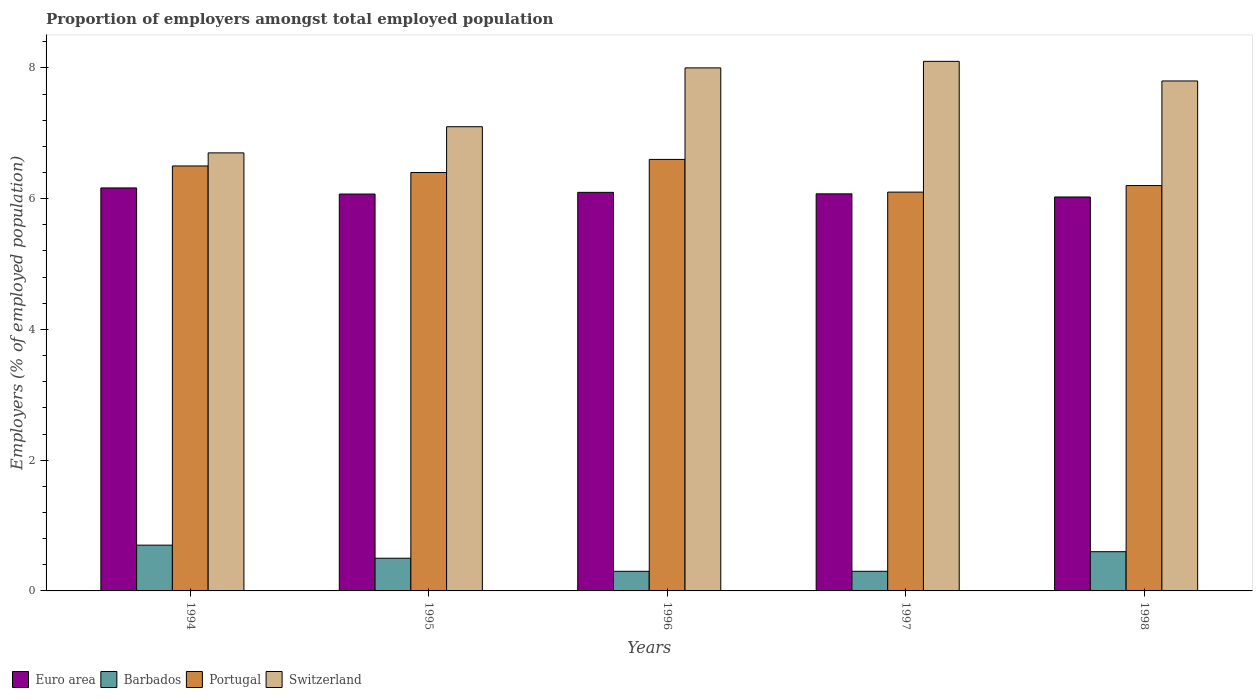How many groups of bars are there?
Provide a short and direct response. 5. Are the number of bars per tick equal to the number of legend labels?
Offer a very short reply. Yes. How many bars are there on the 3rd tick from the right?
Provide a succinct answer. 4. What is the proportion of employers in Portugal in 1996?
Provide a succinct answer. 6.6. Across all years, what is the maximum proportion of employers in Switzerland?
Your response must be concise. 8.1. Across all years, what is the minimum proportion of employers in Barbados?
Your answer should be very brief. 0.3. In which year was the proportion of employers in Switzerland maximum?
Keep it short and to the point. 1997. What is the total proportion of employers in Switzerland in the graph?
Give a very brief answer. 37.7. What is the difference between the proportion of employers in Euro area in 1994 and that in 1997?
Make the answer very short. 0.09. What is the difference between the proportion of employers in Portugal in 1996 and the proportion of employers in Switzerland in 1994?
Provide a short and direct response. -0.1. What is the average proportion of employers in Portugal per year?
Keep it short and to the point. 6.36. In the year 1998, what is the difference between the proportion of employers in Switzerland and proportion of employers in Barbados?
Your response must be concise. 7.2. In how many years, is the proportion of employers in Barbados greater than 0.4 %?
Give a very brief answer. 3. What is the ratio of the proportion of employers in Euro area in 1995 to that in 1997?
Ensure brevity in your answer.  1. Is the difference between the proportion of employers in Switzerland in 1996 and 1997 greater than the difference between the proportion of employers in Barbados in 1996 and 1997?
Ensure brevity in your answer.  No. What is the difference between the highest and the second highest proportion of employers in Switzerland?
Provide a succinct answer. 0.1. What is the difference between the highest and the lowest proportion of employers in Portugal?
Your answer should be very brief. 0.5. Is the sum of the proportion of employers in Barbados in 1994 and 1998 greater than the maximum proportion of employers in Portugal across all years?
Your answer should be very brief. No. What does the 4th bar from the left in 1996 represents?
Your answer should be very brief. Switzerland. What does the 3rd bar from the right in 1994 represents?
Keep it short and to the point. Barbados. How many bars are there?
Make the answer very short. 20. Are the values on the major ticks of Y-axis written in scientific E-notation?
Keep it short and to the point. No. Does the graph contain grids?
Your response must be concise. No. How are the legend labels stacked?
Ensure brevity in your answer.  Horizontal. What is the title of the graph?
Your response must be concise. Proportion of employers amongst total employed population. What is the label or title of the Y-axis?
Your answer should be very brief. Employers (% of employed population). What is the Employers (% of employed population) of Euro area in 1994?
Ensure brevity in your answer.  6.16. What is the Employers (% of employed population) of Barbados in 1994?
Make the answer very short. 0.7. What is the Employers (% of employed population) in Portugal in 1994?
Your response must be concise. 6.5. What is the Employers (% of employed population) of Switzerland in 1994?
Ensure brevity in your answer.  6.7. What is the Employers (% of employed population) of Euro area in 1995?
Your answer should be very brief. 6.07. What is the Employers (% of employed population) of Portugal in 1995?
Your answer should be very brief. 6.4. What is the Employers (% of employed population) in Switzerland in 1995?
Your response must be concise. 7.1. What is the Employers (% of employed population) in Euro area in 1996?
Your response must be concise. 6.1. What is the Employers (% of employed population) of Barbados in 1996?
Provide a succinct answer. 0.3. What is the Employers (% of employed population) of Portugal in 1996?
Ensure brevity in your answer.  6.6. What is the Employers (% of employed population) in Switzerland in 1996?
Your answer should be compact. 8. What is the Employers (% of employed population) of Euro area in 1997?
Give a very brief answer. 6.07. What is the Employers (% of employed population) in Barbados in 1997?
Ensure brevity in your answer.  0.3. What is the Employers (% of employed population) in Portugal in 1997?
Keep it short and to the point. 6.1. What is the Employers (% of employed population) of Switzerland in 1997?
Offer a very short reply. 8.1. What is the Employers (% of employed population) of Euro area in 1998?
Provide a succinct answer. 6.03. What is the Employers (% of employed population) in Barbados in 1998?
Your answer should be compact. 0.6. What is the Employers (% of employed population) in Portugal in 1998?
Your response must be concise. 6.2. What is the Employers (% of employed population) in Switzerland in 1998?
Offer a terse response. 7.8. Across all years, what is the maximum Employers (% of employed population) in Euro area?
Your answer should be very brief. 6.16. Across all years, what is the maximum Employers (% of employed population) of Barbados?
Offer a very short reply. 0.7. Across all years, what is the maximum Employers (% of employed population) of Portugal?
Offer a terse response. 6.6. Across all years, what is the maximum Employers (% of employed population) of Switzerland?
Keep it short and to the point. 8.1. Across all years, what is the minimum Employers (% of employed population) in Euro area?
Make the answer very short. 6.03. Across all years, what is the minimum Employers (% of employed population) of Barbados?
Provide a succinct answer. 0.3. Across all years, what is the minimum Employers (% of employed population) of Portugal?
Your answer should be compact. 6.1. Across all years, what is the minimum Employers (% of employed population) of Switzerland?
Keep it short and to the point. 6.7. What is the total Employers (% of employed population) in Euro area in the graph?
Offer a terse response. 30.43. What is the total Employers (% of employed population) of Barbados in the graph?
Offer a terse response. 2.4. What is the total Employers (% of employed population) of Portugal in the graph?
Your response must be concise. 31.8. What is the total Employers (% of employed population) in Switzerland in the graph?
Provide a succinct answer. 37.7. What is the difference between the Employers (% of employed population) of Euro area in 1994 and that in 1995?
Your response must be concise. 0.09. What is the difference between the Employers (% of employed population) in Barbados in 1994 and that in 1995?
Your response must be concise. 0.2. What is the difference between the Employers (% of employed population) in Portugal in 1994 and that in 1995?
Provide a succinct answer. 0.1. What is the difference between the Employers (% of employed population) in Switzerland in 1994 and that in 1995?
Your answer should be compact. -0.4. What is the difference between the Employers (% of employed population) of Euro area in 1994 and that in 1996?
Ensure brevity in your answer.  0.07. What is the difference between the Employers (% of employed population) in Barbados in 1994 and that in 1996?
Provide a succinct answer. 0.4. What is the difference between the Employers (% of employed population) of Switzerland in 1994 and that in 1996?
Provide a short and direct response. -1.3. What is the difference between the Employers (% of employed population) in Euro area in 1994 and that in 1997?
Your answer should be compact. 0.09. What is the difference between the Employers (% of employed population) in Euro area in 1994 and that in 1998?
Keep it short and to the point. 0.14. What is the difference between the Employers (% of employed population) of Portugal in 1994 and that in 1998?
Provide a short and direct response. 0.3. What is the difference between the Employers (% of employed population) of Euro area in 1995 and that in 1996?
Provide a succinct answer. -0.03. What is the difference between the Employers (% of employed population) in Switzerland in 1995 and that in 1996?
Keep it short and to the point. -0.9. What is the difference between the Employers (% of employed population) of Euro area in 1995 and that in 1997?
Your response must be concise. -0. What is the difference between the Employers (% of employed population) of Portugal in 1995 and that in 1997?
Keep it short and to the point. 0.3. What is the difference between the Employers (% of employed population) of Switzerland in 1995 and that in 1997?
Give a very brief answer. -1. What is the difference between the Employers (% of employed population) in Euro area in 1995 and that in 1998?
Give a very brief answer. 0.05. What is the difference between the Employers (% of employed population) of Portugal in 1995 and that in 1998?
Provide a short and direct response. 0.2. What is the difference between the Employers (% of employed population) in Euro area in 1996 and that in 1997?
Make the answer very short. 0.02. What is the difference between the Employers (% of employed population) in Portugal in 1996 and that in 1997?
Give a very brief answer. 0.5. What is the difference between the Employers (% of employed population) in Switzerland in 1996 and that in 1997?
Your response must be concise. -0.1. What is the difference between the Employers (% of employed population) of Euro area in 1996 and that in 1998?
Give a very brief answer. 0.07. What is the difference between the Employers (% of employed population) of Euro area in 1997 and that in 1998?
Your answer should be very brief. 0.05. What is the difference between the Employers (% of employed population) of Barbados in 1997 and that in 1998?
Keep it short and to the point. -0.3. What is the difference between the Employers (% of employed population) in Switzerland in 1997 and that in 1998?
Make the answer very short. 0.3. What is the difference between the Employers (% of employed population) in Euro area in 1994 and the Employers (% of employed population) in Barbados in 1995?
Your answer should be very brief. 5.66. What is the difference between the Employers (% of employed population) of Euro area in 1994 and the Employers (% of employed population) of Portugal in 1995?
Offer a very short reply. -0.24. What is the difference between the Employers (% of employed population) of Euro area in 1994 and the Employers (% of employed population) of Switzerland in 1995?
Ensure brevity in your answer.  -0.94. What is the difference between the Employers (% of employed population) in Barbados in 1994 and the Employers (% of employed population) in Portugal in 1995?
Your answer should be compact. -5.7. What is the difference between the Employers (% of employed population) in Barbados in 1994 and the Employers (% of employed population) in Switzerland in 1995?
Offer a very short reply. -6.4. What is the difference between the Employers (% of employed population) in Portugal in 1994 and the Employers (% of employed population) in Switzerland in 1995?
Your answer should be very brief. -0.6. What is the difference between the Employers (% of employed population) in Euro area in 1994 and the Employers (% of employed population) in Barbados in 1996?
Provide a succinct answer. 5.86. What is the difference between the Employers (% of employed population) of Euro area in 1994 and the Employers (% of employed population) of Portugal in 1996?
Offer a very short reply. -0.44. What is the difference between the Employers (% of employed population) in Euro area in 1994 and the Employers (% of employed population) in Switzerland in 1996?
Your answer should be very brief. -1.84. What is the difference between the Employers (% of employed population) of Barbados in 1994 and the Employers (% of employed population) of Switzerland in 1996?
Your answer should be compact. -7.3. What is the difference between the Employers (% of employed population) in Portugal in 1994 and the Employers (% of employed population) in Switzerland in 1996?
Your response must be concise. -1.5. What is the difference between the Employers (% of employed population) of Euro area in 1994 and the Employers (% of employed population) of Barbados in 1997?
Your answer should be compact. 5.86. What is the difference between the Employers (% of employed population) in Euro area in 1994 and the Employers (% of employed population) in Portugal in 1997?
Your answer should be very brief. 0.06. What is the difference between the Employers (% of employed population) of Euro area in 1994 and the Employers (% of employed population) of Switzerland in 1997?
Provide a succinct answer. -1.94. What is the difference between the Employers (% of employed population) in Barbados in 1994 and the Employers (% of employed population) in Portugal in 1997?
Your response must be concise. -5.4. What is the difference between the Employers (% of employed population) of Barbados in 1994 and the Employers (% of employed population) of Switzerland in 1997?
Keep it short and to the point. -7.4. What is the difference between the Employers (% of employed population) of Euro area in 1994 and the Employers (% of employed population) of Barbados in 1998?
Offer a terse response. 5.56. What is the difference between the Employers (% of employed population) in Euro area in 1994 and the Employers (% of employed population) in Portugal in 1998?
Provide a short and direct response. -0.04. What is the difference between the Employers (% of employed population) in Euro area in 1994 and the Employers (% of employed population) in Switzerland in 1998?
Ensure brevity in your answer.  -1.64. What is the difference between the Employers (% of employed population) in Portugal in 1994 and the Employers (% of employed population) in Switzerland in 1998?
Ensure brevity in your answer.  -1.3. What is the difference between the Employers (% of employed population) of Euro area in 1995 and the Employers (% of employed population) of Barbados in 1996?
Offer a terse response. 5.77. What is the difference between the Employers (% of employed population) in Euro area in 1995 and the Employers (% of employed population) in Portugal in 1996?
Make the answer very short. -0.53. What is the difference between the Employers (% of employed population) of Euro area in 1995 and the Employers (% of employed population) of Switzerland in 1996?
Ensure brevity in your answer.  -1.93. What is the difference between the Employers (% of employed population) of Barbados in 1995 and the Employers (% of employed population) of Portugal in 1996?
Provide a short and direct response. -6.1. What is the difference between the Employers (% of employed population) of Portugal in 1995 and the Employers (% of employed population) of Switzerland in 1996?
Give a very brief answer. -1.6. What is the difference between the Employers (% of employed population) in Euro area in 1995 and the Employers (% of employed population) in Barbados in 1997?
Provide a succinct answer. 5.77. What is the difference between the Employers (% of employed population) of Euro area in 1995 and the Employers (% of employed population) of Portugal in 1997?
Offer a terse response. -0.03. What is the difference between the Employers (% of employed population) of Euro area in 1995 and the Employers (% of employed population) of Switzerland in 1997?
Offer a terse response. -2.03. What is the difference between the Employers (% of employed population) in Barbados in 1995 and the Employers (% of employed population) in Portugal in 1997?
Your response must be concise. -5.6. What is the difference between the Employers (% of employed population) in Barbados in 1995 and the Employers (% of employed population) in Switzerland in 1997?
Ensure brevity in your answer.  -7.6. What is the difference between the Employers (% of employed population) of Portugal in 1995 and the Employers (% of employed population) of Switzerland in 1997?
Your answer should be compact. -1.7. What is the difference between the Employers (% of employed population) of Euro area in 1995 and the Employers (% of employed population) of Barbados in 1998?
Provide a short and direct response. 5.47. What is the difference between the Employers (% of employed population) in Euro area in 1995 and the Employers (% of employed population) in Portugal in 1998?
Provide a succinct answer. -0.13. What is the difference between the Employers (% of employed population) in Euro area in 1995 and the Employers (% of employed population) in Switzerland in 1998?
Provide a short and direct response. -1.73. What is the difference between the Employers (% of employed population) in Barbados in 1995 and the Employers (% of employed population) in Portugal in 1998?
Make the answer very short. -5.7. What is the difference between the Employers (% of employed population) in Barbados in 1995 and the Employers (% of employed population) in Switzerland in 1998?
Provide a succinct answer. -7.3. What is the difference between the Employers (% of employed population) in Portugal in 1995 and the Employers (% of employed population) in Switzerland in 1998?
Ensure brevity in your answer.  -1.4. What is the difference between the Employers (% of employed population) in Euro area in 1996 and the Employers (% of employed population) in Barbados in 1997?
Provide a succinct answer. 5.8. What is the difference between the Employers (% of employed population) in Euro area in 1996 and the Employers (% of employed population) in Portugal in 1997?
Provide a short and direct response. -0. What is the difference between the Employers (% of employed population) of Euro area in 1996 and the Employers (% of employed population) of Switzerland in 1997?
Make the answer very short. -2. What is the difference between the Employers (% of employed population) in Barbados in 1996 and the Employers (% of employed population) in Portugal in 1997?
Provide a succinct answer. -5.8. What is the difference between the Employers (% of employed population) of Barbados in 1996 and the Employers (% of employed population) of Switzerland in 1997?
Provide a succinct answer. -7.8. What is the difference between the Employers (% of employed population) in Portugal in 1996 and the Employers (% of employed population) in Switzerland in 1997?
Provide a short and direct response. -1.5. What is the difference between the Employers (% of employed population) in Euro area in 1996 and the Employers (% of employed population) in Barbados in 1998?
Keep it short and to the point. 5.5. What is the difference between the Employers (% of employed population) in Euro area in 1996 and the Employers (% of employed population) in Portugal in 1998?
Keep it short and to the point. -0.1. What is the difference between the Employers (% of employed population) in Euro area in 1996 and the Employers (% of employed population) in Switzerland in 1998?
Your answer should be compact. -1.7. What is the difference between the Employers (% of employed population) in Barbados in 1996 and the Employers (% of employed population) in Switzerland in 1998?
Your answer should be very brief. -7.5. What is the difference between the Employers (% of employed population) in Portugal in 1996 and the Employers (% of employed population) in Switzerland in 1998?
Your answer should be very brief. -1.2. What is the difference between the Employers (% of employed population) of Euro area in 1997 and the Employers (% of employed population) of Barbados in 1998?
Your answer should be very brief. 5.47. What is the difference between the Employers (% of employed population) of Euro area in 1997 and the Employers (% of employed population) of Portugal in 1998?
Provide a succinct answer. -0.13. What is the difference between the Employers (% of employed population) of Euro area in 1997 and the Employers (% of employed population) of Switzerland in 1998?
Offer a very short reply. -1.73. What is the average Employers (% of employed population) in Euro area per year?
Give a very brief answer. 6.09. What is the average Employers (% of employed population) in Barbados per year?
Offer a terse response. 0.48. What is the average Employers (% of employed population) in Portugal per year?
Keep it short and to the point. 6.36. What is the average Employers (% of employed population) of Switzerland per year?
Keep it short and to the point. 7.54. In the year 1994, what is the difference between the Employers (% of employed population) of Euro area and Employers (% of employed population) of Barbados?
Offer a terse response. 5.46. In the year 1994, what is the difference between the Employers (% of employed population) in Euro area and Employers (% of employed population) in Portugal?
Provide a succinct answer. -0.34. In the year 1994, what is the difference between the Employers (% of employed population) in Euro area and Employers (% of employed population) in Switzerland?
Make the answer very short. -0.54. In the year 1995, what is the difference between the Employers (% of employed population) of Euro area and Employers (% of employed population) of Barbados?
Make the answer very short. 5.57. In the year 1995, what is the difference between the Employers (% of employed population) in Euro area and Employers (% of employed population) in Portugal?
Make the answer very short. -0.33. In the year 1995, what is the difference between the Employers (% of employed population) in Euro area and Employers (% of employed population) in Switzerland?
Give a very brief answer. -1.03. In the year 1995, what is the difference between the Employers (% of employed population) in Portugal and Employers (% of employed population) in Switzerland?
Make the answer very short. -0.7. In the year 1996, what is the difference between the Employers (% of employed population) in Euro area and Employers (% of employed population) in Barbados?
Ensure brevity in your answer.  5.8. In the year 1996, what is the difference between the Employers (% of employed population) in Euro area and Employers (% of employed population) in Portugal?
Your response must be concise. -0.5. In the year 1996, what is the difference between the Employers (% of employed population) in Euro area and Employers (% of employed population) in Switzerland?
Provide a short and direct response. -1.9. In the year 1996, what is the difference between the Employers (% of employed population) in Barbados and Employers (% of employed population) in Portugal?
Offer a very short reply. -6.3. In the year 1997, what is the difference between the Employers (% of employed population) in Euro area and Employers (% of employed population) in Barbados?
Your response must be concise. 5.77. In the year 1997, what is the difference between the Employers (% of employed population) of Euro area and Employers (% of employed population) of Portugal?
Your answer should be very brief. -0.03. In the year 1997, what is the difference between the Employers (% of employed population) in Euro area and Employers (% of employed population) in Switzerland?
Offer a terse response. -2.03. In the year 1997, what is the difference between the Employers (% of employed population) in Barbados and Employers (% of employed population) in Switzerland?
Make the answer very short. -7.8. In the year 1997, what is the difference between the Employers (% of employed population) in Portugal and Employers (% of employed population) in Switzerland?
Offer a very short reply. -2. In the year 1998, what is the difference between the Employers (% of employed population) in Euro area and Employers (% of employed population) in Barbados?
Offer a very short reply. 5.43. In the year 1998, what is the difference between the Employers (% of employed population) in Euro area and Employers (% of employed population) in Portugal?
Give a very brief answer. -0.17. In the year 1998, what is the difference between the Employers (% of employed population) in Euro area and Employers (% of employed population) in Switzerland?
Provide a short and direct response. -1.77. In the year 1998, what is the difference between the Employers (% of employed population) in Barbados and Employers (% of employed population) in Portugal?
Your answer should be compact. -5.6. In the year 1998, what is the difference between the Employers (% of employed population) in Portugal and Employers (% of employed population) in Switzerland?
Provide a short and direct response. -1.6. What is the ratio of the Employers (% of employed population) of Euro area in 1994 to that in 1995?
Offer a terse response. 1.02. What is the ratio of the Employers (% of employed population) of Portugal in 1994 to that in 1995?
Your answer should be very brief. 1.02. What is the ratio of the Employers (% of employed population) in Switzerland in 1994 to that in 1995?
Your answer should be compact. 0.94. What is the ratio of the Employers (% of employed population) in Euro area in 1994 to that in 1996?
Make the answer very short. 1.01. What is the ratio of the Employers (% of employed population) of Barbados in 1994 to that in 1996?
Provide a succinct answer. 2.33. What is the ratio of the Employers (% of employed population) of Switzerland in 1994 to that in 1996?
Provide a short and direct response. 0.84. What is the ratio of the Employers (% of employed population) of Euro area in 1994 to that in 1997?
Your answer should be very brief. 1.01. What is the ratio of the Employers (% of employed population) of Barbados in 1994 to that in 1997?
Your answer should be compact. 2.33. What is the ratio of the Employers (% of employed population) in Portugal in 1994 to that in 1997?
Your answer should be compact. 1.07. What is the ratio of the Employers (% of employed population) in Switzerland in 1994 to that in 1997?
Give a very brief answer. 0.83. What is the ratio of the Employers (% of employed population) in Euro area in 1994 to that in 1998?
Your answer should be compact. 1.02. What is the ratio of the Employers (% of employed population) in Barbados in 1994 to that in 1998?
Your response must be concise. 1.17. What is the ratio of the Employers (% of employed population) of Portugal in 1994 to that in 1998?
Provide a succinct answer. 1.05. What is the ratio of the Employers (% of employed population) in Switzerland in 1994 to that in 1998?
Provide a succinct answer. 0.86. What is the ratio of the Employers (% of employed population) of Portugal in 1995 to that in 1996?
Provide a succinct answer. 0.97. What is the ratio of the Employers (% of employed population) of Switzerland in 1995 to that in 1996?
Your response must be concise. 0.89. What is the ratio of the Employers (% of employed population) in Portugal in 1995 to that in 1997?
Make the answer very short. 1.05. What is the ratio of the Employers (% of employed population) in Switzerland in 1995 to that in 1997?
Your response must be concise. 0.88. What is the ratio of the Employers (% of employed population) in Euro area in 1995 to that in 1998?
Keep it short and to the point. 1.01. What is the ratio of the Employers (% of employed population) in Portugal in 1995 to that in 1998?
Your answer should be very brief. 1.03. What is the ratio of the Employers (% of employed population) of Switzerland in 1995 to that in 1998?
Your response must be concise. 0.91. What is the ratio of the Employers (% of employed population) of Euro area in 1996 to that in 1997?
Offer a terse response. 1. What is the ratio of the Employers (% of employed population) in Barbados in 1996 to that in 1997?
Your answer should be very brief. 1. What is the ratio of the Employers (% of employed population) of Portugal in 1996 to that in 1997?
Your answer should be very brief. 1.08. What is the ratio of the Employers (% of employed population) of Switzerland in 1996 to that in 1997?
Give a very brief answer. 0.99. What is the ratio of the Employers (% of employed population) of Euro area in 1996 to that in 1998?
Ensure brevity in your answer.  1.01. What is the ratio of the Employers (% of employed population) of Barbados in 1996 to that in 1998?
Keep it short and to the point. 0.5. What is the ratio of the Employers (% of employed population) of Portugal in 1996 to that in 1998?
Provide a short and direct response. 1.06. What is the ratio of the Employers (% of employed population) in Switzerland in 1996 to that in 1998?
Your response must be concise. 1.03. What is the ratio of the Employers (% of employed population) in Euro area in 1997 to that in 1998?
Offer a very short reply. 1.01. What is the ratio of the Employers (% of employed population) of Portugal in 1997 to that in 1998?
Offer a terse response. 0.98. What is the difference between the highest and the second highest Employers (% of employed population) of Euro area?
Give a very brief answer. 0.07. What is the difference between the highest and the second highest Employers (% of employed population) of Switzerland?
Your response must be concise. 0.1. What is the difference between the highest and the lowest Employers (% of employed population) in Euro area?
Offer a very short reply. 0.14. 